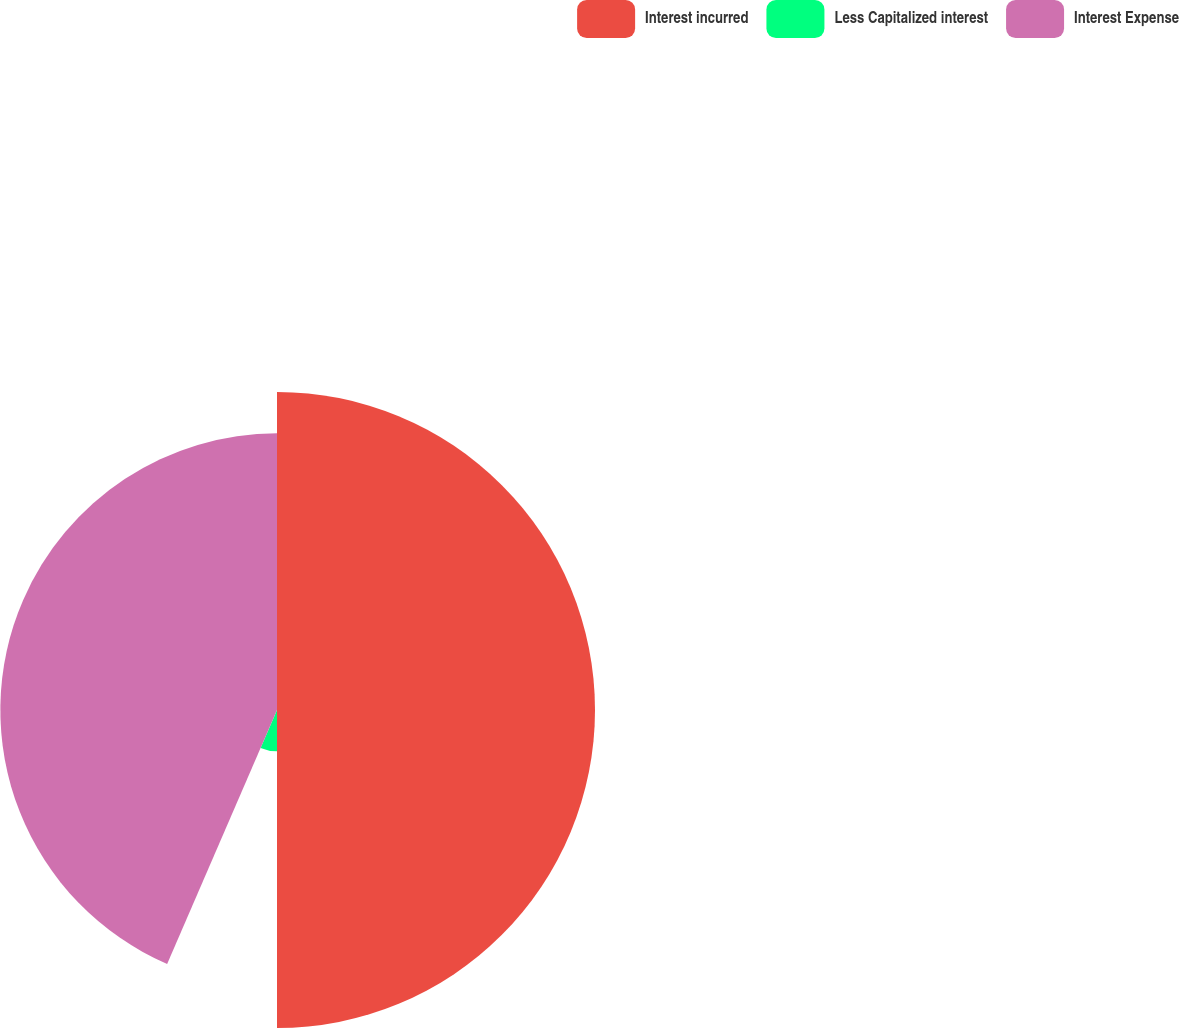Convert chart to OTSL. <chart><loc_0><loc_0><loc_500><loc_500><pie_chart><fcel>Interest incurred<fcel>Less Capitalized interest<fcel>Interest Expense<nl><fcel>50.0%<fcel>6.5%<fcel>43.5%<nl></chart> 